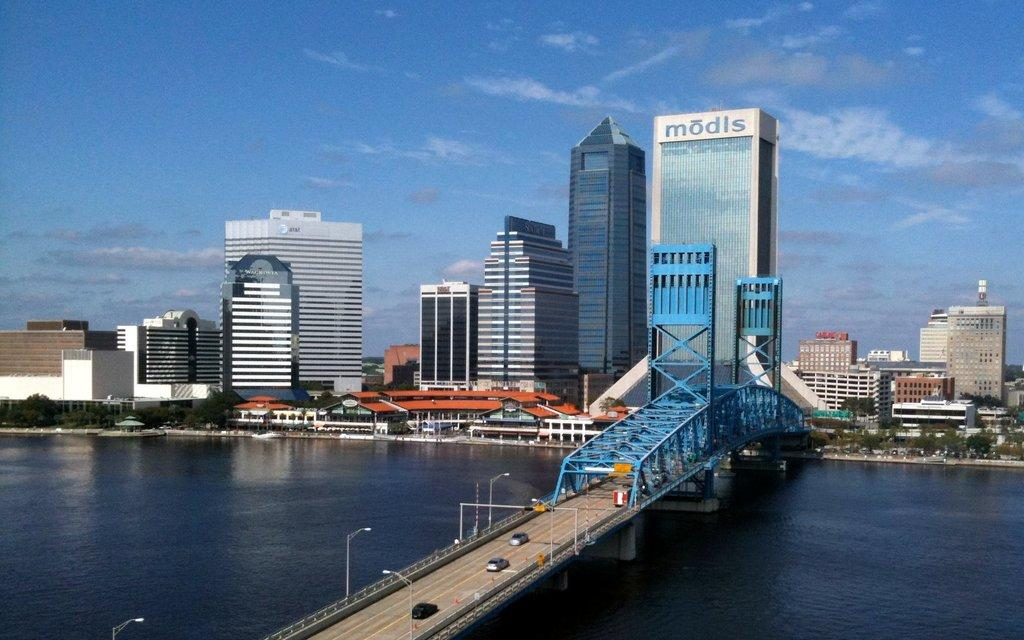What type of structures can be seen in the image? There are buildings in the image. What is crossing over the river in the image? There is a bridge over a river in the image. What mode of transportation can be seen on the road? Motor vehicles are visible on the road. What type of lighting is present in the image? Street lights are present in the image. What type of poles are visible in the image? Street poles are visible in the image. What type of vegetation is present in the image? Trees are present in the image. What part of the natural environment is visible in the image? The sky is visible in the image. What can be seen in the sky in the image? Clouds are present in the sky. Where is the cat hiding in the image? There is no cat present in the image. Who is the porter assisting in the image? There is no porter present in the image. 